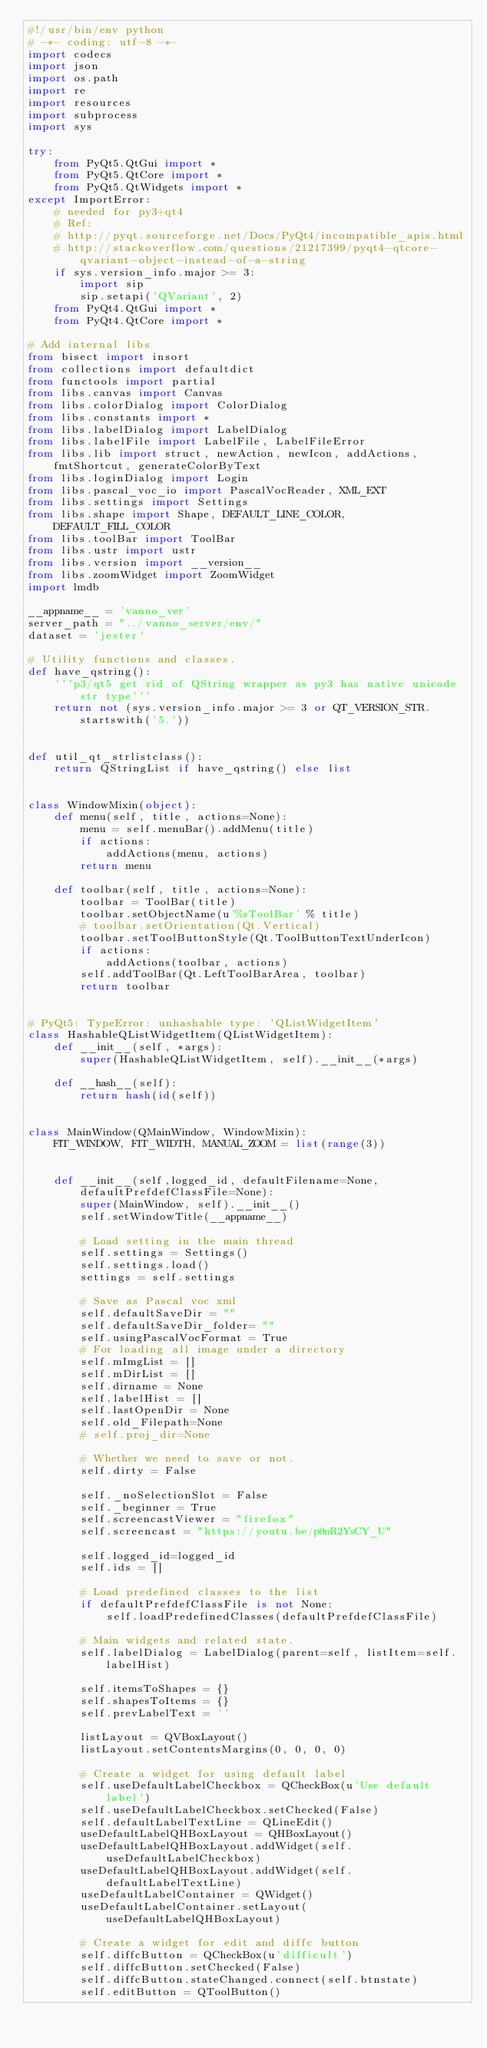Convert code to text. <code><loc_0><loc_0><loc_500><loc_500><_Python_>#!/usr/bin/env python
# -*- coding: utf-8 -*-
import codecs
import json
import os.path
import re
import resources
import subprocess
import sys

try:
    from PyQt5.QtGui import *
    from PyQt5.QtCore import *
    from PyQt5.QtWidgets import *
except ImportError:
    # needed for py3+qt4
    # Ref:
    # http://pyqt.sourceforge.net/Docs/PyQt4/incompatible_apis.html
    # http://stackoverflow.com/questions/21217399/pyqt4-qtcore-qvariant-object-instead-of-a-string
    if sys.version_info.major >= 3:
        import sip
        sip.setapi('QVariant', 2)
    from PyQt4.QtGui import *
    from PyQt4.QtCore import *

# Add internal libs
from bisect import insort
from collections import defaultdict
from functools import partial
from libs.canvas import Canvas
from libs.colorDialog import ColorDialog
from libs.constants import *
from libs.labelDialog import LabelDialog
from libs.labelFile import LabelFile, LabelFileError
from libs.lib import struct, newAction, newIcon, addActions, fmtShortcut, generateColorByText
from libs.loginDialog import Login
from libs.pascal_voc_io import PascalVocReader, XML_EXT
from libs.settings import Settings
from libs.shape import Shape, DEFAULT_LINE_COLOR, DEFAULT_FILL_COLOR
from libs.toolBar import ToolBar
from libs.ustr import ustr
from libs.version import __version__
from libs.zoomWidget import ZoomWidget
import lmdb

__appname__ = 'vanno_ver'
server_path = "../vanno_server/env/"
dataset = 'jester'

# Utility functions and classes.
def have_qstring():
    '''p3/qt5 get rid of QString wrapper as py3 has native unicode str type'''
    return not (sys.version_info.major >= 3 or QT_VERSION_STR.startswith('5.'))


def util_qt_strlistclass():
    return QStringList if have_qstring() else list


class WindowMixin(object):
    def menu(self, title, actions=None):
        menu = self.menuBar().addMenu(title)
        if actions:
            addActions(menu, actions)
        return menu

    def toolbar(self, title, actions=None):
        toolbar = ToolBar(title)
        toolbar.setObjectName(u'%sToolBar' % title)
        # toolbar.setOrientation(Qt.Vertical)
        toolbar.setToolButtonStyle(Qt.ToolButtonTextUnderIcon)
        if actions:
            addActions(toolbar, actions)
        self.addToolBar(Qt.LeftToolBarArea, toolbar)
        return toolbar


# PyQt5: TypeError: unhashable type: 'QListWidgetItem'
class HashableQListWidgetItem(QListWidgetItem):
    def __init__(self, *args):
        super(HashableQListWidgetItem, self).__init__(*args)

    def __hash__(self):
        return hash(id(self))


class MainWindow(QMainWindow, WindowMixin):
    FIT_WINDOW, FIT_WIDTH, MANUAL_ZOOM = list(range(3))


    def __init__(self,logged_id, defaultFilename=None, defaultPrefdefClassFile=None):
        super(MainWindow, self).__init__()
        self.setWindowTitle(__appname__)

        # Load setting in the main thread
        self.settings = Settings()
        self.settings.load()
        settings = self.settings

        # Save as Pascal voc xml
        self.defaultSaveDir = ""
        self.defaultSaveDir_folder= ""
        self.usingPascalVocFormat = True
        # For loading all image under a directory
        self.mImgList = []
        self.mDirList = []
        self.dirname = None
        self.labelHist = []
        self.lastOpenDir = None
        self.old_Filepath=None
        # self.proj_dir=None

        # Whether we need to save or not.
        self.dirty = False

        self._noSelectionSlot = False
        self._beginner = True
        self.screencastViewer = "firefox"
        self.screencast = "https://youtu.be/p0nR2YsCY_U"

        self.logged_id=logged_id
        self.ids = []

        # Load predefined classes to the list
        if defaultPrefdefClassFile is not None:
            self.loadPredefinedClasses(defaultPrefdefClassFile)

        # Main widgets and related state.
        self.labelDialog = LabelDialog(parent=self, listItem=self.labelHist)

        self.itemsToShapes = {}
        self.shapesToItems = {}
        self.prevLabelText = ''

        listLayout = QVBoxLayout()
        listLayout.setContentsMargins(0, 0, 0, 0)

        # Create a widget for using default label
        self.useDefaultLabelCheckbox = QCheckBox(u'Use default label')
        self.useDefaultLabelCheckbox.setChecked(False)
        self.defaultLabelTextLine = QLineEdit()
        useDefaultLabelQHBoxLayout = QHBoxLayout()
        useDefaultLabelQHBoxLayout.addWidget(self.useDefaultLabelCheckbox)
        useDefaultLabelQHBoxLayout.addWidget(self.defaultLabelTextLine)
        useDefaultLabelContainer = QWidget()
        useDefaultLabelContainer.setLayout(useDefaultLabelQHBoxLayout)

        # Create a widget for edit and diffc button
        self.diffcButton = QCheckBox(u'difficult')
        self.diffcButton.setChecked(False)
        self.diffcButton.stateChanged.connect(self.btnstate)
        self.editButton = QToolButton()</code> 